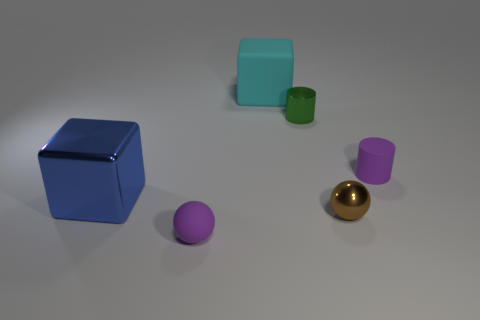Add 3 tiny purple matte balls. How many objects exist? 9 Subtract all balls. How many objects are left? 4 Subtract all big yellow cylinders. Subtract all small green cylinders. How many objects are left? 5 Add 2 tiny spheres. How many tiny spheres are left? 4 Add 1 yellow rubber cylinders. How many yellow rubber cylinders exist? 1 Subtract 0 gray balls. How many objects are left? 6 